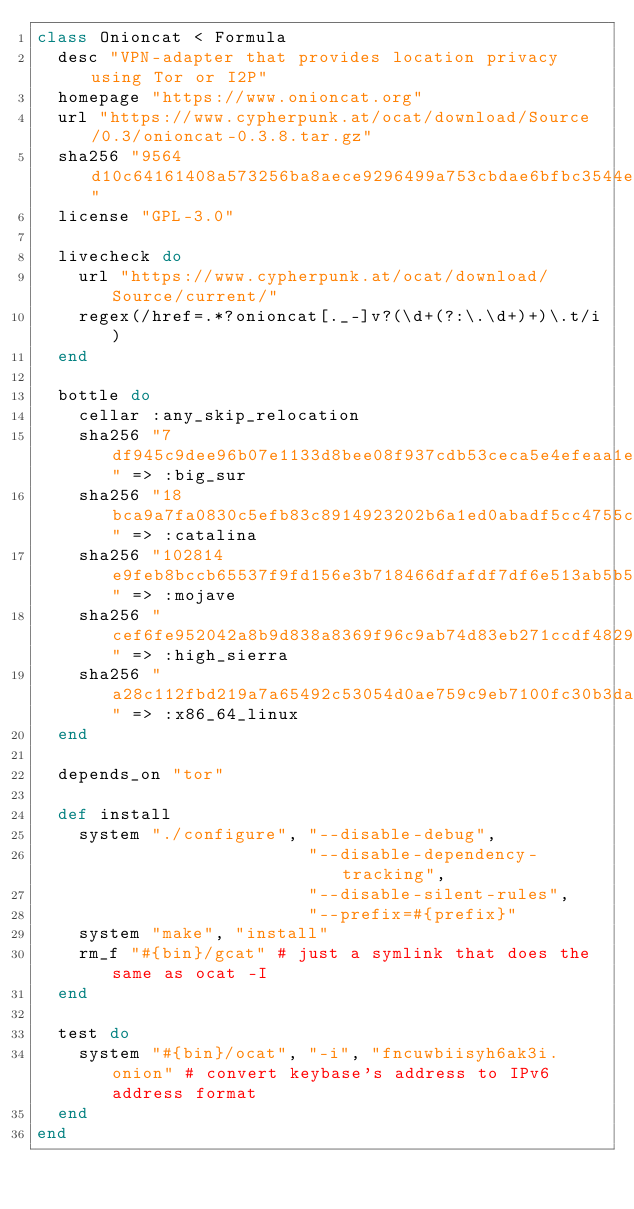Convert code to text. <code><loc_0><loc_0><loc_500><loc_500><_Ruby_>class Onioncat < Formula
  desc "VPN-adapter that provides location privacy using Tor or I2P"
  homepage "https://www.onioncat.org"
  url "https://www.cypherpunk.at/ocat/download/Source/0.3/onioncat-0.3.8.tar.gz"
  sha256 "9564d10c64161408a573256ba8aece9296499a753cbdae6bfbc3544e72a1d63b"
  license "GPL-3.0"

  livecheck do
    url "https://www.cypherpunk.at/ocat/download/Source/current/"
    regex(/href=.*?onioncat[._-]v?(\d+(?:\.\d+)+)\.t/i)
  end

  bottle do
    cellar :any_skip_relocation
    sha256 "7df945c9dee96b07e1133d8bee08f937cdb53ceca5e4efeaa1e0f2093018c405" => :big_sur
    sha256 "18bca9a7fa0830c5efb83c8914923202b6a1ed0abadf5cc4755c04c54978e3eb" => :catalina
    sha256 "102814e9feb8bccb65537f9fd156e3b718466dfafdf7df6e513ab5b5e3560ff3" => :mojave
    sha256 "cef6fe952042a8b9d838a8369f96c9ab74d83eb271ccdf4829e0b23ba89dee58" => :high_sierra
    sha256 "a28c112fbd219a7a65492c53054d0ae759c9eb7100fc30b3da76a48583023285" => :x86_64_linux
  end

  depends_on "tor"

  def install
    system "./configure", "--disable-debug",
                          "--disable-dependency-tracking",
                          "--disable-silent-rules",
                          "--prefix=#{prefix}"
    system "make", "install"
    rm_f "#{bin}/gcat" # just a symlink that does the same as ocat -I
  end

  test do
    system "#{bin}/ocat", "-i", "fncuwbiisyh6ak3i.onion" # convert keybase's address to IPv6 address format
  end
end
</code> 